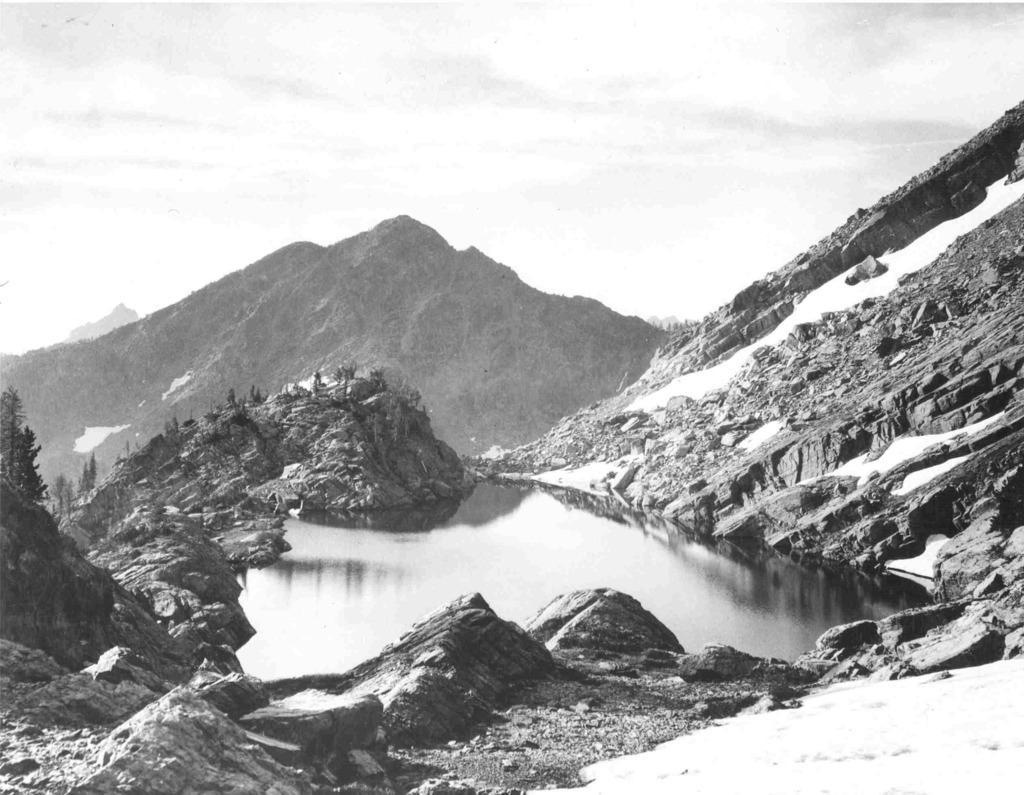Can you describe this image briefly? In this picture we can see mountain, rocks on rocks trees and water surrounded through the mountains. 